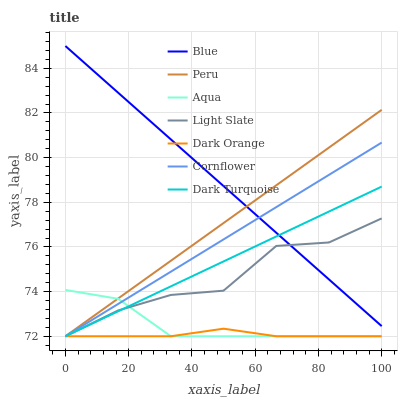Does Dark Orange have the minimum area under the curve?
Answer yes or no. Yes. Does Cornflower have the minimum area under the curve?
Answer yes or no. No. Does Cornflower have the maximum area under the curve?
Answer yes or no. No. Is Cornflower the smoothest?
Answer yes or no. No. Is Cornflower the roughest?
Answer yes or no. No. Does Cornflower have the highest value?
Answer yes or no. No. Is Aqua less than Blue?
Answer yes or no. Yes. Is Blue greater than Dark Orange?
Answer yes or no. Yes. Does Aqua intersect Blue?
Answer yes or no. No. 